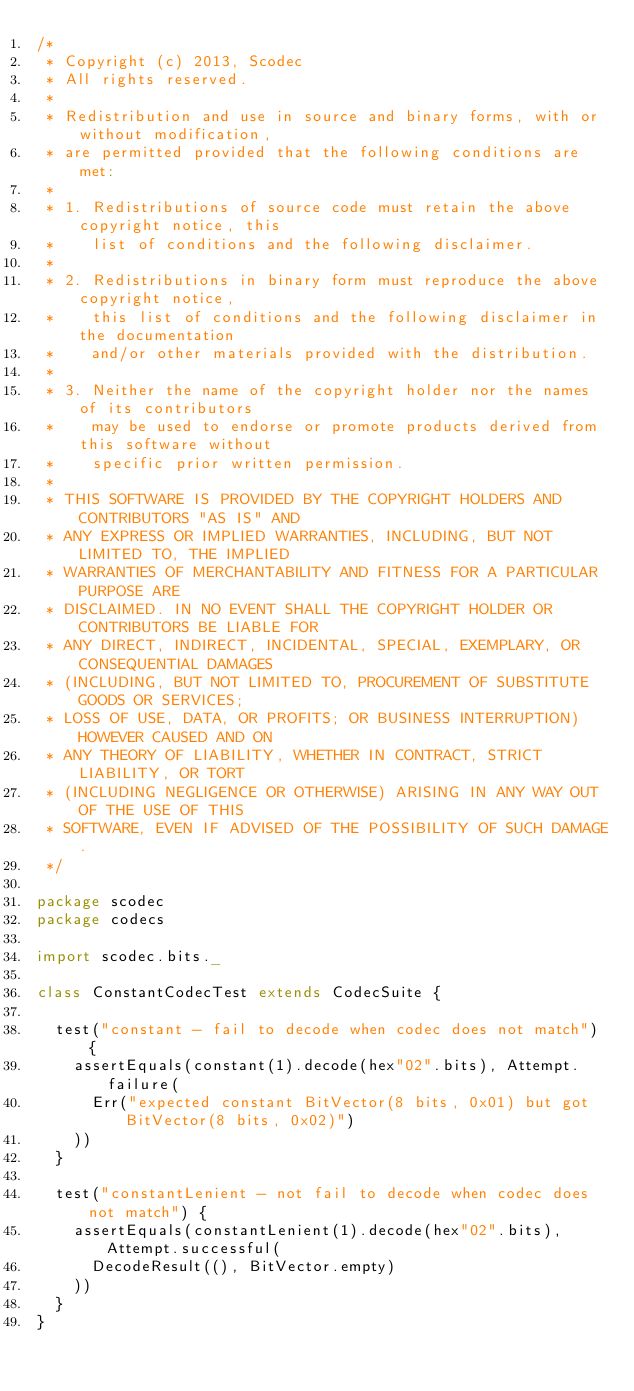Convert code to text. <code><loc_0><loc_0><loc_500><loc_500><_Scala_>/*
 * Copyright (c) 2013, Scodec
 * All rights reserved.
 *
 * Redistribution and use in source and binary forms, with or without modification,
 * are permitted provided that the following conditions are met:
 *
 * 1. Redistributions of source code must retain the above copyright notice, this
 *    list of conditions and the following disclaimer.
 *
 * 2. Redistributions in binary form must reproduce the above copyright notice,
 *    this list of conditions and the following disclaimer in the documentation
 *    and/or other materials provided with the distribution.
 *
 * 3. Neither the name of the copyright holder nor the names of its contributors
 *    may be used to endorse or promote products derived from this software without
 *    specific prior written permission.
 *
 * THIS SOFTWARE IS PROVIDED BY THE COPYRIGHT HOLDERS AND CONTRIBUTORS "AS IS" AND
 * ANY EXPRESS OR IMPLIED WARRANTIES, INCLUDING, BUT NOT LIMITED TO, THE IMPLIED
 * WARRANTIES OF MERCHANTABILITY AND FITNESS FOR A PARTICULAR PURPOSE ARE
 * DISCLAIMED. IN NO EVENT SHALL THE COPYRIGHT HOLDER OR CONTRIBUTORS BE LIABLE FOR
 * ANY DIRECT, INDIRECT, INCIDENTAL, SPECIAL, EXEMPLARY, OR CONSEQUENTIAL DAMAGES
 * (INCLUDING, BUT NOT LIMITED TO, PROCUREMENT OF SUBSTITUTE GOODS OR SERVICES;
 * LOSS OF USE, DATA, OR PROFITS; OR BUSINESS INTERRUPTION) HOWEVER CAUSED AND ON
 * ANY THEORY OF LIABILITY, WHETHER IN CONTRACT, STRICT LIABILITY, OR TORT
 * (INCLUDING NEGLIGENCE OR OTHERWISE) ARISING IN ANY WAY OUT OF THE USE OF THIS
 * SOFTWARE, EVEN IF ADVISED OF THE POSSIBILITY OF SUCH DAMAGE.
 */

package scodec
package codecs

import scodec.bits._

class ConstantCodecTest extends CodecSuite {

  test("constant - fail to decode when codec does not match") {
    assertEquals(constant(1).decode(hex"02".bits), Attempt.failure(
      Err("expected constant BitVector(8 bits, 0x01) but got BitVector(8 bits, 0x02)")
    ))
  }

  test("constantLenient - not fail to decode when codec does not match") {
    assertEquals(constantLenient(1).decode(hex"02".bits), Attempt.successful(
      DecodeResult((), BitVector.empty)
    ))
  }
}
</code> 